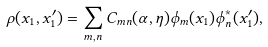Convert formula to latex. <formula><loc_0><loc_0><loc_500><loc_500>\rho ( x _ { 1 } , x _ { 1 } ^ { \prime } ) = \sum _ { m , n } C _ { m n } ( \alpha , \eta ) \phi _ { m } ( x _ { 1 } ) \phi ^ { * } _ { n } ( x _ { 1 } ^ { \prime } ) ,</formula> 